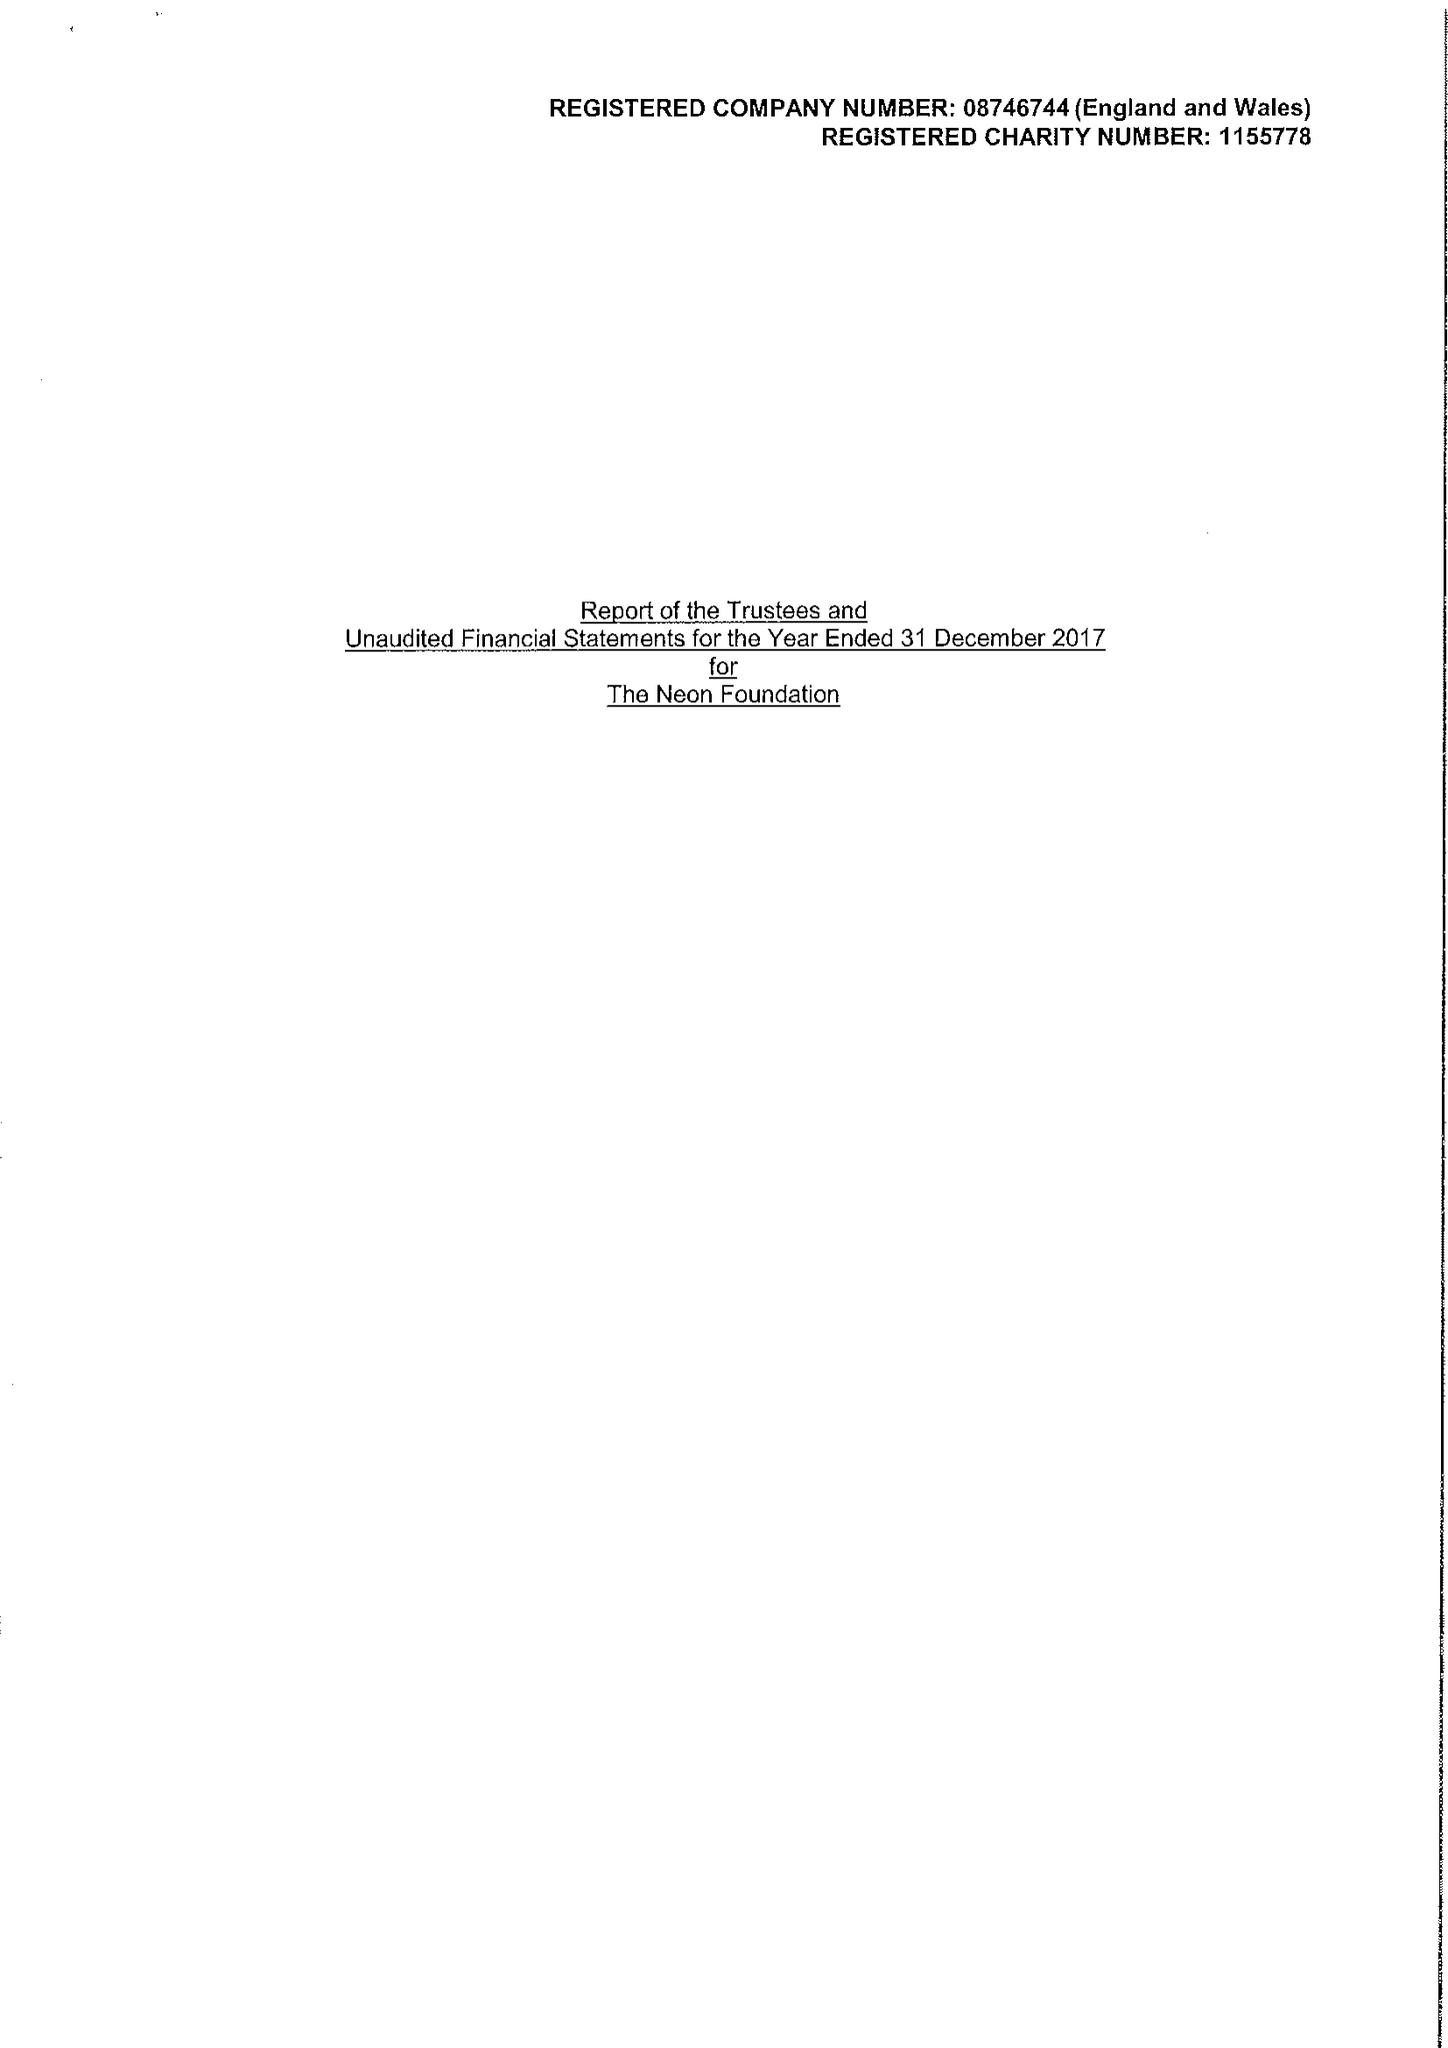What is the value for the address__street_line?
Answer the question using a single word or phrase. 15-19 BAKER'S ROW 